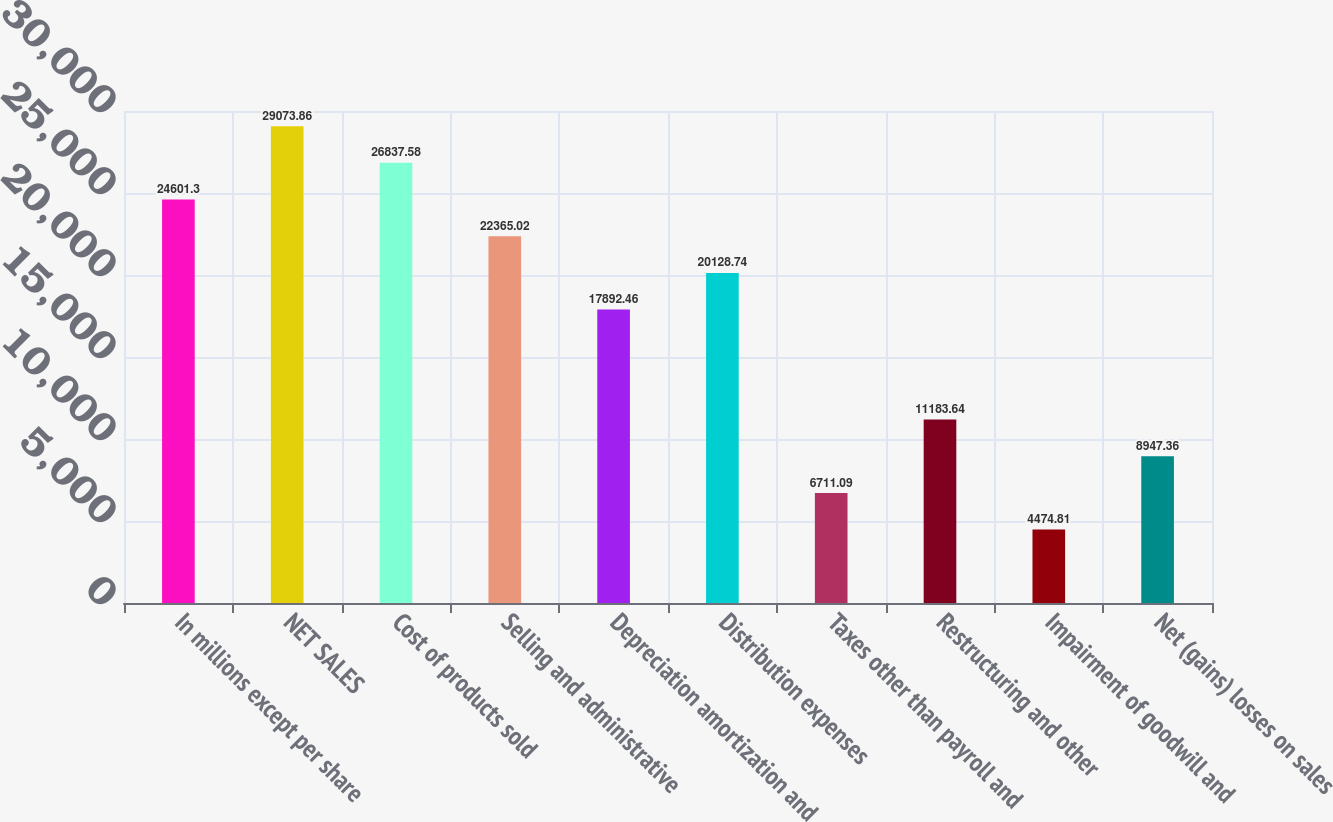Convert chart. <chart><loc_0><loc_0><loc_500><loc_500><bar_chart><fcel>In millions except per share<fcel>NET SALES<fcel>Cost of products sold<fcel>Selling and administrative<fcel>Depreciation amortization and<fcel>Distribution expenses<fcel>Taxes other than payroll and<fcel>Restructuring and other<fcel>Impairment of goodwill and<fcel>Net (gains) losses on sales<nl><fcel>24601.3<fcel>29073.9<fcel>26837.6<fcel>22365<fcel>17892.5<fcel>20128.7<fcel>6711.09<fcel>11183.6<fcel>4474.81<fcel>8947.36<nl></chart> 